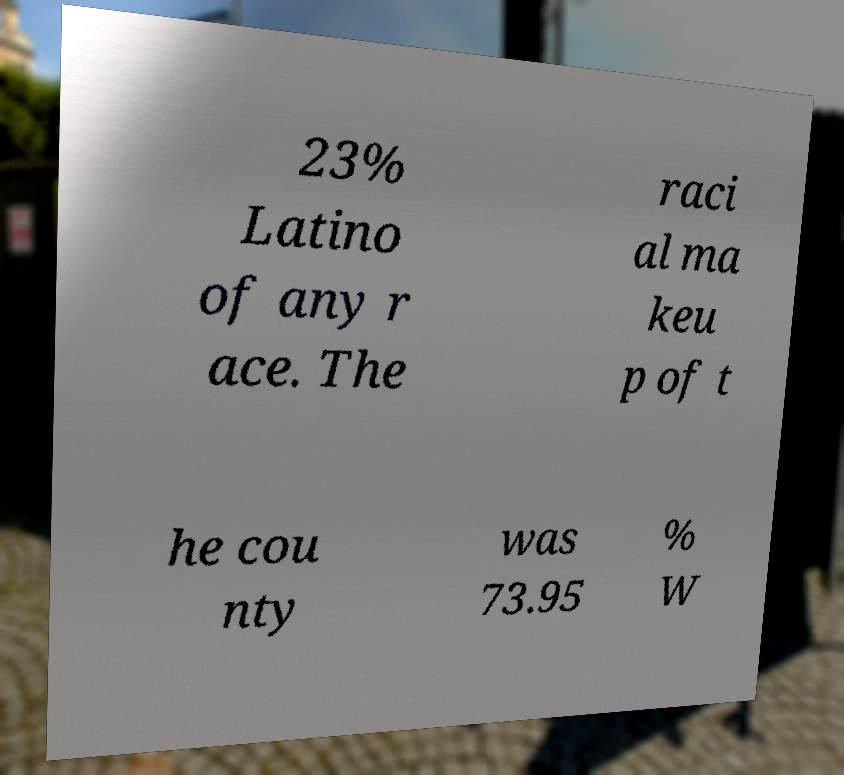I need the written content from this picture converted into text. Can you do that? 23% Latino of any r ace. The raci al ma keu p of t he cou nty was 73.95 % W 